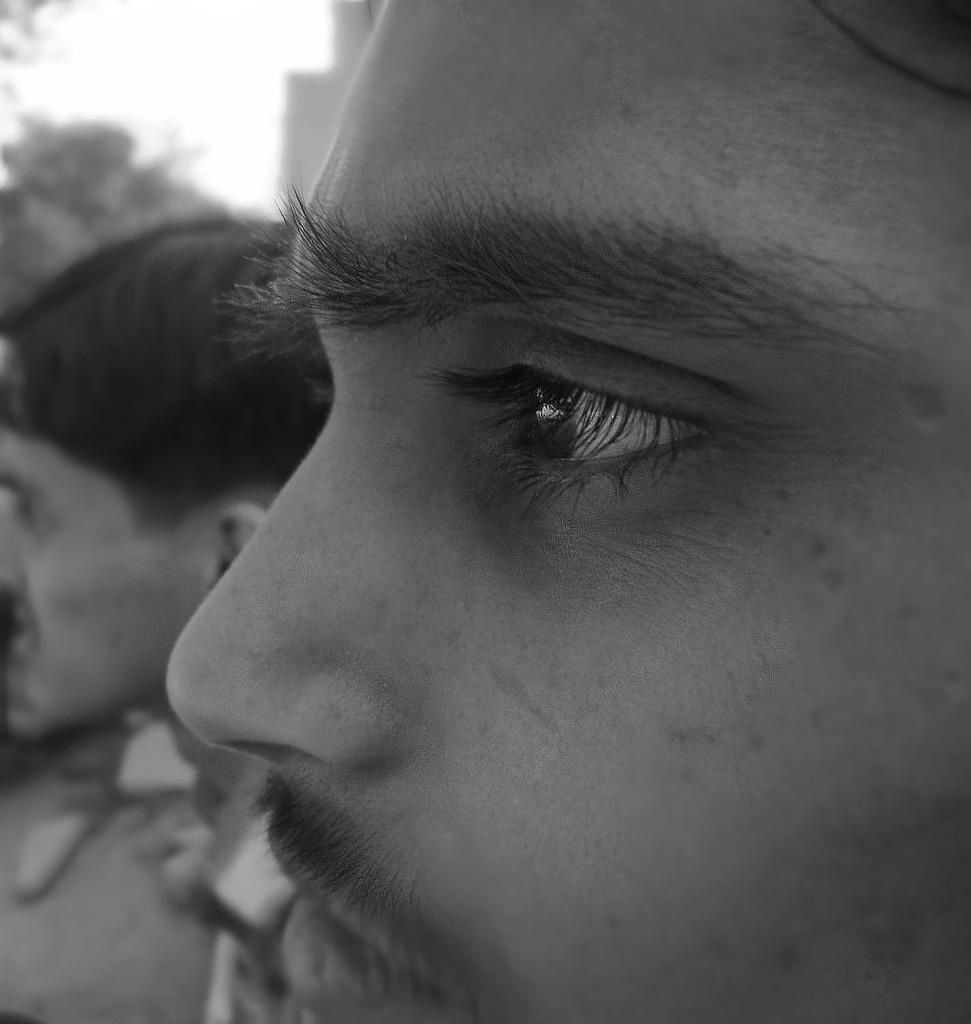Could you give a brief overview of what you see in this image? This image is a black and white image. This image is taken outdoors. At the top left of the image there is the sky and there is a tree. On the left side of the image there is a man. On the right side of the image there is a face of a man. 